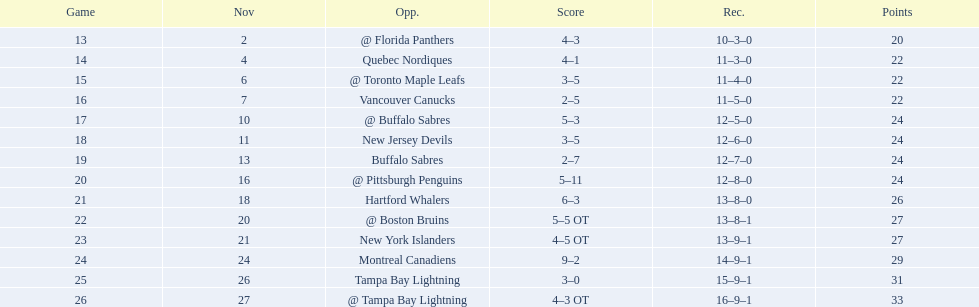What were the scores of the 1993-94 philadelphia flyers season? 4–3, 4–1, 3–5, 2–5, 5–3, 3–5, 2–7, 5–11, 6–3, 5–5 OT, 4–5 OT, 9–2, 3–0, 4–3 OT. Which of these teams had the score 4-5 ot? New York Islanders. 